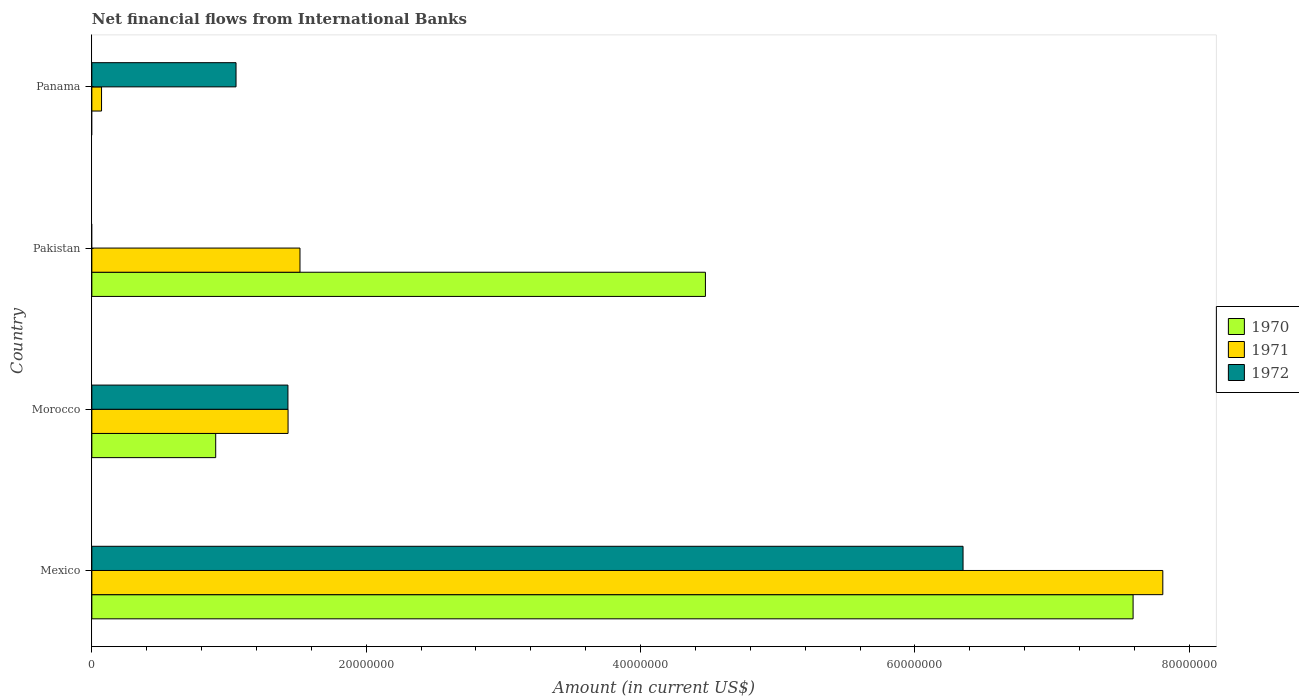How many different coloured bars are there?
Give a very brief answer. 3. How many groups of bars are there?
Make the answer very short. 4. Are the number of bars per tick equal to the number of legend labels?
Make the answer very short. No. How many bars are there on the 3rd tick from the top?
Ensure brevity in your answer.  3. What is the label of the 3rd group of bars from the top?
Make the answer very short. Morocco. In how many cases, is the number of bars for a given country not equal to the number of legend labels?
Your answer should be very brief. 2. What is the net financial aid flows in 1971 in Morocco?
Offer a very short reply. 1.43e+07. Across all countries, what is the maximum net financial aid flows in 1972?
Ensure brevity in your answer.  6.35e+07. What is the total net financial aid flows in 1970 in the graph?
Your answer should be compact. 1.30e+08. What is the difference between the net financial aid flows in 1972 in Mexico and that in Panama?
Keep it short and to the point. 5.30e+07. What is the difference between the net financial aid flows in 1970 in Morocco and the net financial aid flows in 1972 in Mexico?
Your answer should be very brief. -5.45e+07. What is the average net financial aid flows in 1971 per country?
Give a very brief answer. 2.71e+07. What is the difference between the net financial aid flows in 1971 and net financial aid flows in 1970 in Mexico?
Your answer should be compact. 2.17e+06. In how many countries, is the net financial aid flows in 1972 greater than 44000000 US$?
Your response must be concise. 1. What is the ratio of the net financial aid flows in 1972 in Mexico to that in Panama?
Offer a terse response. 6.04. Is the net financial aid flows in 1971 in Morocco less than that in Pakistan?
Provide a short and direct response. Yes. Is the difference between the net financial aid flows in 1971 in Mexico and Morocco greater than the difference between the net financial aid flows in 1970 in Mexico and Morocco?
Ensure brevity in your answer.  No. What is the difference between the highest and the second highest net financial aid flows in 1971?
Keep it short and to the point. 6.29e+07. What is the difference between the highest and the lowest net financial aid flows in 1971?
Provide a short and direct response. 7.74e+07. In how many countries, is the net financial aid flows in 1971 greater than the average net financial aid flows in 1971 taken over all countries?
Provide a succinct answer. 1. Are all the bars in the graph horizontal?
Your answer should be very brief. Yes. Does the graph contain any zero values?
Your response must be concise. Yes. How are the legend labels stacked?
Provide a short and direct response. Vertical. What is the title of the graph?
Provide a short and direct response. Net financial flows from International Banks. What is the Amount (in current US$) in 1970 in Mexico?
Your response must be concise. 7.59e+07. What is the Amount (in current US$) of 1971 in Mexico?
Ensure brevity in your answer.  7.81e+07. What is the Amount (in current US$) of 1972 in Mexico?
Give a very brief answer. 6.35e+07. What is the Amount (in current US$) in 1970 in Morocco?
Provide a short and direct response. 9.03e+06. What is the Amount (in current US$) of 1971 in Morocco?
Your answer should be very brief. 1.43e+07. What is the Amount (in current US$) of 1972 in Morocco?
Give a very brief answer. 1.43e+07. What is the Amount (in current US$) of 1970 in Pakistan?
Provide a succinct answer. 4.47e+07. What is the Amount (in current US$) of 1971 in Pakistan?
Your response must be concise. 1.52e+07. What is the Amount (in current US$) of 1972 in Pakistan?
Offer a terse response. 0. What is the Amount (in current US$) of 1971 in Panama?
Ensure brevity in your answer.  7.07e+05. What is the Amount (in current US$) in 1972 in Panama?
Ensure brevity in your answer.  1.05e+07. Across all countries, what is the maximum Amount (in current US$) of 1970?
Make the answer very short. 7.59e+07. Across all countries, what is the maximum Amount (in current US$) in 1971?
Keep it short and to the point. 7.81e+07. Across all countries, what is the maximum Amount (in current US$) in 1972?
Ensure brevity in your answer.  6.35e+07. Across all countries, what is the minimum Amount (in current US$) of 1970?
Offer a terse response. 0. Across all countries, what is the minimum Amount (in current US$) of 1971?
Keep it short and to the point. 7.07e+05. What is the total Amount (in current US$) of 1970 in the graph?
Offer a very short reply. 1.30e+08. What is the total Amount (in current US$) in 1971 in the graph?
Ensure brevity in your answer.  1.08e+08. What is the total Amount (in current US$) in 1972 in the graph?
Your answer should be compact. 8.83e+07. What is the difference between the Amount (in current US$) of 1970 in Mexico and that in Morocco?
Offer a terse response. 6.69e+07. What is the difference between the Amount (in current US$) of 1971 in Mexico and that in Morocco?
Offer a very short reply. 6.38e+07. What is the difference between the Amount (in current US$) of 1972 in Mexico and that in Morocco?
Keep it short and to the point. 4.92e+07. What is the difference between the Amount (in current US$) of 1970 in Mexico and that in Pakistan?
Offer a terse response. 3.12e+07. What is the difference between the Amount (in current US$) of 1971 in Mexico and that in Pakistan?
Provide a succinct answer. 6.29e+07. What is the difference between the Amount (in current US$) in 1971 in Mexico and that in Panama?
Make the answer very short. 7.74e+07. What is the difference between the Amount (in current US$) in 1972 in Mexico and that in Panama?
Your answer should be compact. 5.30e+07. What is the difference between the Amount (in current US$) in 1970 in Morocco and that in Pakistan?
Make the answer very short. -3.57e+07. What is the difference between the Amount (in current US$) in 1971 in Morocco and that in Pakistan?
Provide a succinct answer. -8.69e+05. What is the difference between the Amount (in current US$) in 1971 in Morocco and that in Panama?
Offer a terse response. 1.36e+07. What is the difference between the Amount (in current US$) of 1972 in Morocco and that in Panama?
Your answer should be very brief. 3.78e+06. What is the difference between the Amount (in current US$) of 1971 in Pakistan and that in Panama?
Keep it short and to the point. 1.45e+07. What is the difference between the Amount (in current US$) in 1970 in Mexico and the Amount (in current US$) in 1971 in Morocco?
Ensure brevity in your answer.  6.16e+07. What is the difference between the Amount (in current US$) of 1970 in Mexico and the Amount (in current US$) of 1972 in Morocco?
Make the answer very short. 6.16e+07. What is the difference between the Amount (in current US$) of 1971 in Mexico and the Amount (in current US$) of 1972 in Morocco?
Make the answer very short. 6.38e+07. What is the difference between the Amount (in current US$) of 1970 in Mexico and the Amount (in current US$) of 1971 in Pakistan?
Give a very brief answer. 6.07e+07. What is the difference between the Amount (in current US$) of 1970 in Mexico and the Amount (in current US$) of 1971 in Panama?
Your response must be concise. 7.52e+07. What is the difference between the Amount (in current US$) in 1970 in Mexico and the Amount (in current US$) in 1972 in Panama?
Your answer should be compact. 6.54e+07. What is the difference between the Amount (in current US$) of 1971 in Mexico and the Amount (in current US$) of 1972 in Panama?
Make the answer very short. 6.76e+07. What is the difference between the Amount (in current US$) of 1970 in Morocco and the Amount (in current US$) of 1971 in Pakistan?
Your answer should be very brief. -6.14e+06. What is the difference between the Amount (in current US$) in 1970 in Morocco and the Amount (in current US$) in 1971 in Panama?
Make the answer very short. 8.32e+06. What is the difference between the Amount (in current US$) of 1970 in Morocco and the Amount (in current US$) of 1972 in Panama?
Offer a terse response. -1.48e+06. What is the difference between the Amount (in current US$) in 1971 in Morocco and the Amount (in current US$) in 1972 in Panama?
Make the answer very short. 3.79e+06. What is the difference between the Amount (in current US$) in 1970 in Pakistan and the Amount (in current US$) in 1971 in Panama?
Your response must be concise. 4.40e+07. What is the difference between the Amount (in current US$) of 1970 in Pakistan and the Amount (in current US$) of 1972 in Panama?
Offer a terse response. 3.42e+07. What is the difference between the Amount (in current US$) in 1971 in Pakistan and the Amount (in current US$) in 1972 in Panama?
Offer a very short reply. 4.66e+06. What is the average Amount (in current US$) in 1970 per country?
Keep it short and to the point. 3.24e+07. What is the average Amount (in current US$) in 1971 per country?
Ensure brevity in your answer.  2.71e+07. What is the average Amount (in current US$) in 1972 per country?
Give a very brief answer. 2.21e+07. What is the difference between the Amount (in current US$) of 1970 and Amount (in current US$) of 1971 in Mexico?
Your answer should be very brief. -2.17e+06. What is the difference between the Amount (in current US$) in 1970 and Amount (in current US$) in 1972 in Mexico?
Ensure brevity in your answer.  1.24e+07. What is the difference between the Amount (in current US$) of 1971 and Amount (in current US$) of 1972 in Mexico?
Provide a short and direct response. 1.46e+07. What is the difference between the Amount (in current US$) in 1970 and Amount (in current US$) in 1971 in Morocco?
Offer a terse response. -5.28e+06. What is the difference between the Amount (in current US$) of 1970 and Amount (in current US$) of 1972 in Morocco?
Keep it short and to the point. -5.27e+06. What is the difference between the Amount (in current US$) of 1970 and Amount (in current US$) of 1971 in Pakistan?
Provide a succinct answer. 2.96e+07. What is the difference between the Amount (in current US$) of 1971 and Amount (in current US$) of 1972 in Panama?
Offer a terse response. -9.80e+06. What is the ratio of the Amount (in current US$) in 1970 in Mexico to that in Morocco?
Your answer should be compact. 8.41. What is the ratio of the Amount (in current US$) of 1971 in Mexico to that in Morocco?
Provide a succinct answer. 5.46. What is the ratio of the Amount (in current US$) in 1972 in Mexico to that in Morocco?
Offer a terse response. 4.44. What is the ratio of the Amount (in current US$) in 1970 in Mexico to that in Pakistan?
Keep it short and to the point. 1.7. What is the ratio of the Amount (in current US$) in 1971 in Mexico to that in Pakistan?
Offer a terse response. 5.15. What is the ratio of the Amount (in current US$) in 1971 in Mexico to that in Panama?
Your response must be concise. 110.43. What is the ratio of the Amount (in current US$) of 1972 in Mexico to that in Panama?
Offer a terse response. 6.04. What is the ratio of the Amount (in current US$) of 1970 in Morocco to that in Pakistan?
Ensure brevity in your answer.  0.2. What is the ratio of the Amount (in current US$) in 1971 in Morocco to that in Pakistan?
Offer a very short reply. 0.94. What is the ratio of the Amount (in current US$) of 1971 in Morocco to that in Panama?
Provide a succinct answer. 20.23. What is the ratio of the Amount (in current US$) of 1972 in Morocco to that in Panama?
Offer a very short reply. 1.36. What is the ratio of the Amount (in current US$) in 1971 in Pakistan to that in Panama?
Provide a succinct answer. 21.46. What is the difference between the highest and the second highest Amount (in current US$) of 1970?
Offer a terse response. 3.12e+07. What is the difference between the highest and the second highest Amount (in current US$) of 1971?
Make the answer very short. 6.29e+07. What is the difference between the highest and the second highest Amount (in current US$) in 1972?
Make the answer very short. 4.92e+07. What is the difference between the highest and the lowest Amount (in current US$) of 1970?
Your answer should be compact. 7.59e+07. What is the difference between the highest and the lowest Amount (in current US$) in 1971?
Give a very brief answer. 7.74e+07. What is the difference between the highest and the lowest Amount (in current US$) in 1972?
Give a very brief answer. 6.35e+07. 